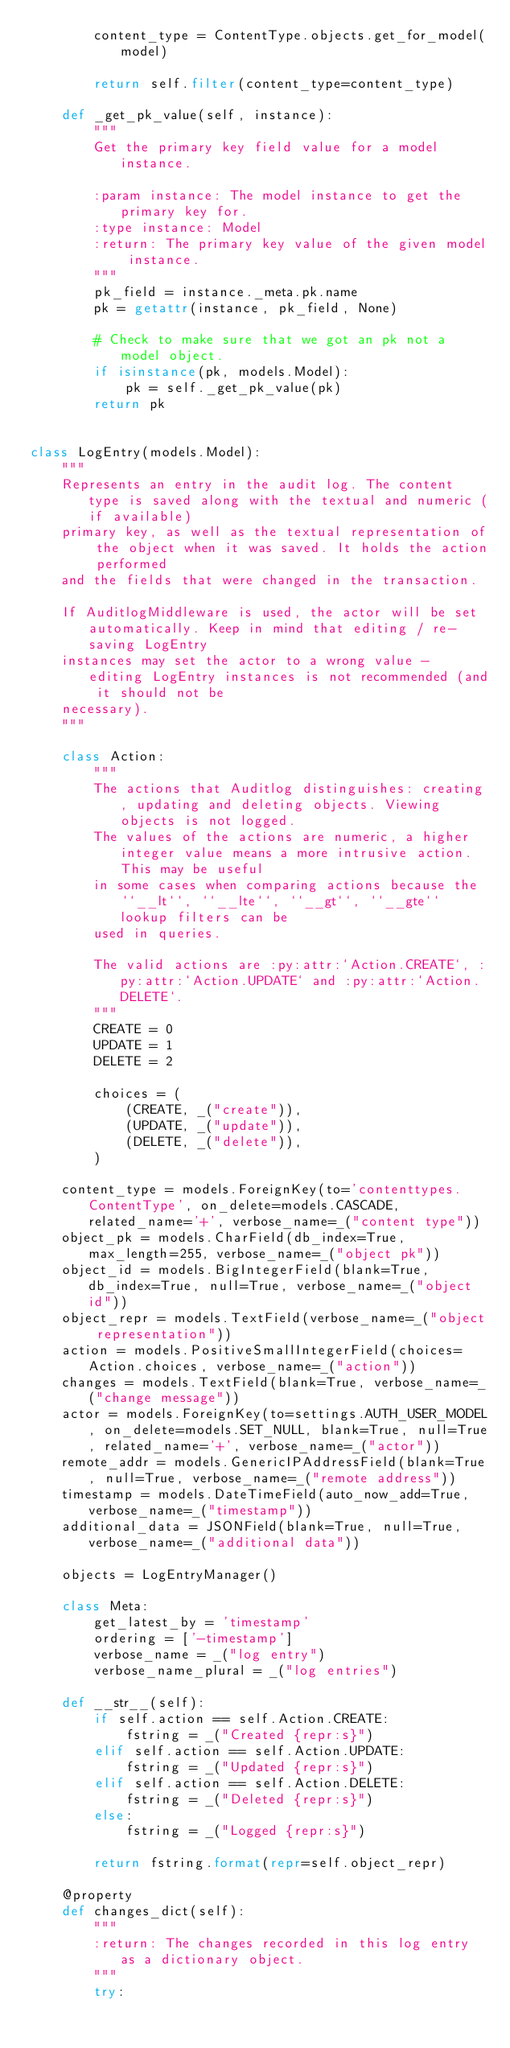Convert code to text. <code><loc_0><loc_0><loc_500><loc_500><_Python_>        content_type = ContentType.objects.get_for_model(model)

        return self.filter(content_type=content_type)

    def _get_pk_value(self, instance):
        """
        Get the primary key field value for a model instance.

        :param instance: The model instance to get the primary key for.
        :type instance: Model
        :return: The primary key value of the given model instance.
        """
        pk_field = instance._meta.pk.name
        pk = getattr(instance, pk_field, None)

        # Check to make sure that we got an pk not a model object.
        if isinstance(pk, models.Model):
            pk = self._get_pk_value(pk)
        return pk


class LogEntry(models.Model):
    """
    Represents an entry in the audit log. The content type is saved along with the textual and numeric (if available)
    primary key, as well as the textual representation of the object when it was saved. It holds the action performed
    and the fields that were changed in the transaction.

    If AuditlogMiddleware is used, the actor will be set automatically. Keep in mind that editing / re-saving LogEntry
    instances may set the actor to a wrong value - editing LogEntry instances is not recommended (and it should not be
    necessary).
    """

    class Action:
        """
        The actions that Auditlog distinguishes: creating, updating and deleting objects. Viewing objects is not logged.
        The values of the actions are numeric, a higher integer value means a more intrusive action. This may be useful
        in some cases when comparing actions because the ``__lt``, ``__lte``, ``__gt``, ``__gte`` lookup filters can be
        used in queries.

        The valid actions are :py:attr:`Action.CREATE`, :py:attr:`Action.UPDATE` and :py:attr:`Action.DELETE`.
        """
        CREATE = 0
        UPDATE = 1
        DELETE = 2

        choices = (
            (CREATE, _("create")),
            (UPDATE, _("update")),
            (DELETE, _("delete")),
        )

    content_type = models.ForeignKey(to='contenttypes.ContentType', on_delete=models.CASCADE, related_name='+', verbose_name=_("content type"))
    object_pk = models.CharField(db_index=True, max_length=255, verbose_name=_("object pk"))
    object_id = models.BigIntegerField(blank=True, db_index=True, null=True, verbose_name=_("object id"))
    object_repr = models.TextField(verbose_name=_("object representation"))
    action = models.PositiveSmallIntegerField(choices=Action.choices, verbose_name=_("action"))
    changes = models.TextField(blank=True, verbose_name=_("change message"))
    actor = models.ForeignKey(to=settings.AUTH_USER_MODEL, on_delete=models.SET_NULL, blank=True, null=True, related_name='+', verbose_name=_("actor"))
    remote_addr = models.GenericIPAddressField(blank=True, null=True, verbose_name=_("remote address"))
    timestamp = models.DateTimeField(auto_now_add=True, verbose_name=_("timestamp"))
    additional_data = JSONField(blank=True, null=True, verbose_name=_("additional data"))

    objects = LogEntryManager()

    class Meta:
        get_latest_by = 'timestamp'
        ordering = ['-timestamp']
        verbose_name = _("log entry")
        verbose_name_plural = _("log entries")

    def __str__(self):
        if self.action == self.Action.CREATE:
            fstring = _("Created {repr:s}")
        elif self.action == self.Action.UPDATE:
            fstring = _("Updated {repr:s}")
        elif self.action == self.Action.DELETE:
            fstring = _("Deleted {repr:s}")
        else:
            fstring = _("Logged {repr:s}")

        return fstring.format(repr=self.object_repr)

    @property
    def changes_dict(self):
        """
        :return: The changes recorded in this log entry as a dictionary object.
        """
        try:</code> 